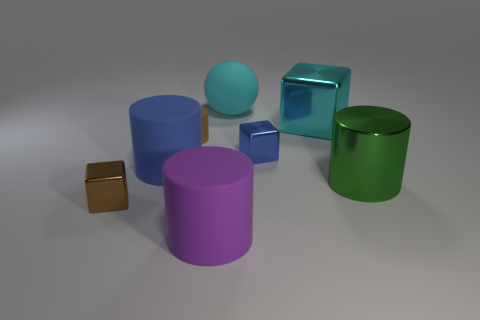Add 2 big cyan objects. How many objects exist? 10 Subtract all blue cylinders. How many cylinders are left? 3 Subtract all large green cylinders. How many cylinders are left? 3 Subtract 1 cylinders. How many cylinders are left? 3 Subtract 1 brown cylinders. How many objects are left? 7 Subtract all cubes. How many objects are left? 5 Subtract all yellow cylinders. Subtract all purple spheres. How many cylinders are left? 4 Subtract all cyan cylinders. How many brown blocks are left? 1 Subtract all red objects. Subtract all cylinders. How many objects are left? 4 Add 3 brown metallic blocks. How many brown metallic blocks are left? 4 